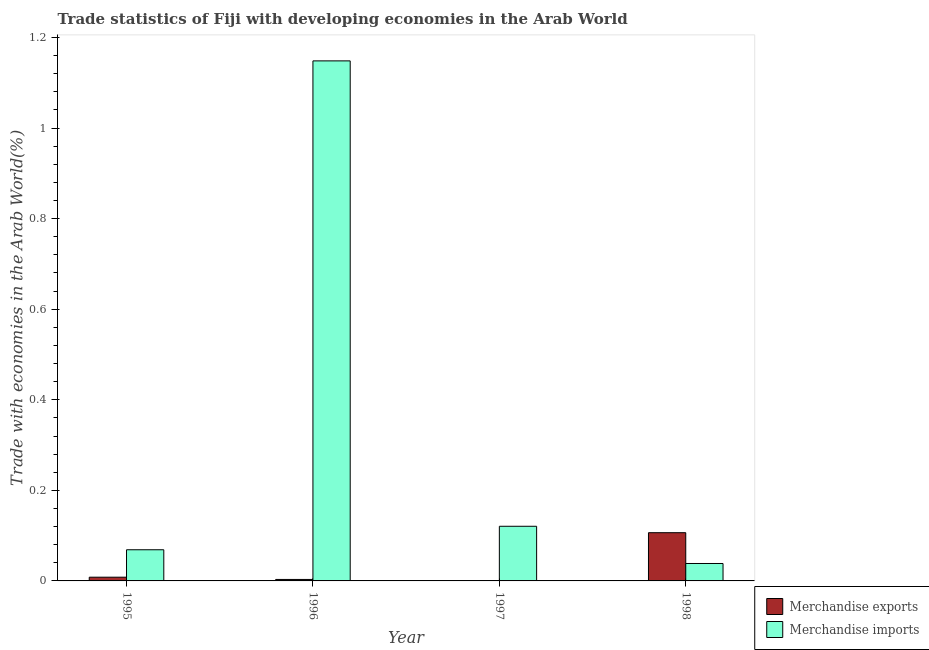How many groups of bars are there?
Your answer should be very brief. 4. How many bars are there on the 2nd tick from the left?
Provide a succinct answer. 2. What is the label of the 4th group of bars from the left?
Your answer should be very brief. 1998. What is the merchandise exports in 1996?
Keep it short and to the point. 0. Across all years, what is the maximum merchandise exports?
Make the answer very short. 0.11. Across all years, what is the minimum merchandise exports?
Ensure brevity in your answer.  0. What is the total merchandise imports in the graph?
Offer a terse response. 1.38. What is the difference between the merchandise exports in 1995 and that in 1997?
Ensure brevity in your answer.  0.01. What is the difference between the merchandise imports in 1996 and the merchandise exports in 1998?
Give a very brief answer. 1.11. What is the average merchandise imports per year?
Offer a very short reply. 0.34. What is the ratio of the merchandise exports in 1997 to that in 1998?
Your answer should be compact. 0. What is the difference between the highest and the second highest merchandise exports?
Provide a short and direct response. 0.1. What is the difference between the highest and the lowest merchandise imports?
Ensure brevity in your answer.  1.11. In how many years, is the merchandise exports greater than the average merchandise exports taken over all years?
Your answer should be compact. 1. Is the sum of the merchandise exports in 1996 and 1998 greater than the maximum merchandise imports across all years?
Offer a terse response. Yes. What does the 1st bar from the left in 1997 represents?
Provide a succinct answer. Merchandise exports. How many bars are there?
Your answer should be compact. 8. What is the difference between two consecutive major ticks on the Y-axis?
Make the answer very short. 0.2. Are the values on the major ticks of Y-axis written in scientific E-notation?
Provide a succinct answer. No. Does the graph contain grids?
Your answer should be compact. No. How many legend labels are there?
Your answer should be very brief. 2. What is the title of the graph?
Make the answer very short. Trade statistics of Fiji with developing economies in the Arab World. What is the label or title of the X-axis?
Offer a very short reply. Year. What is the label or title of the Y-axis?
Your answer should be compact. Trade with economies in the Arab World(%). What is the Trade with economies in the Arab World(%) of Merchandise exports in 1995?
Your response must be concise. 0.01. What is the Trade with economies in the Arab World(%) in Merchandise imports in 1995?
Make the answer very short. 0.07. What is the Trade with economies in the Arab World(%) of Merchandise exports in 1996?
Provide a succinct answer. 0. What is the Trade with economies in the Arab World(%) in Merchandise imports in 1996?
Offer a terse response. 1.15. What is the Trade with economies in the Arab World(%) in Merchandise exports in 1997?
Give a very brief answer. 0. What is the Trade with economies in the Arab World(%) in Merchandise imports in 1997?
Give a very brief answer. 0.12. What is the Trade with economies in the Arab World(%) of Merchandise exports in 1998?
Your answer should be very brief. 0.11. What is the Trade with economies in the Arab World(%) of Merchandise imports in 1998?
Your answer should be compact. 0.04. Across all years, what is the maximum Trade with economies in the Arab World(%) in Merchandise exports?
Provide a succinct answer. 0.11. Across all years, what is the maximum Trade with economies in the Arab World(%) of Merchandise imports?
Give a very brief answer. 1.15. Across all years, what is the minimum Trade with economies in the Arab World(%) in Merchandise exports?
Ensure brevity in your answer.  0. Across all years, what is the minimum Trade with economies in the Arab World(%) in Merchandise imports?
Provide a short and direct response. 0.04. What is the total Trade with economies in the Arab World(%) of Merchandise exports in the graph?
Your answer should be compact. 0.12. What is the total Trade with economies in the Arab World(%) of Merchandise imports in the graph?
Give a very brief answer. 1.38. What is the difference between the Trade with economies in the Arab World(%) of Merchandise exports in 1995 and that in 1996?
Give a very brief answer. 0.01. What is the difference between the Trade with economies in the Arab World(%) of Merchandise imports in 1995 and that in 1996?
Provide a succinct answer. -1.08. What is the difference between the Trade with economies in the Arab World(%) in Merchandise exports in 1995 and that in 1997?
Provide a short and direct response. 0.01. What is the difference between the Trade with economies in the Arab World(%) in Merchandise imports in 1995 and that in 1997?
Give a very brief answer. -0.05. What is the difference between the Trade with economies in the Arab World(%) of Merchandise exports in 1995 and that in 1998?
Provide a succinct answer. -0.1. What is the difference between the Trade with economies in the Arab World(%) of Merchandise imports in 1995 and that in 1998?
Give a very brief answer. 0.03. What is the difference between the Trade with economies in the Arab World(%) in Merchandise exports in 1996 and that in 1997?
Offer a very short reply. 0. What is the difference between the Trade with economies in the Arab World(%) of Merchandise imports in 1996 and that in 1997?
Keep it short and to the point. 1.03. What is the difference between the Trade with economies in the Arab World(%) of Merchandise exports in 1996 and that in 1998?
Offer a very short reply. -0.1. What is the difference between the Trade with economies in the Arab World(%) in Merchandise imports in 1996 and that in 1998?
Offer a terse response. 1.11. What is the difference between the Trade with economies in the Arab World(%) of Merchandise exports in 1997 and that in 1998?
Your response must be concise. -0.11. What is the difference between the Trade with economies in the Arab World(%) in Merchandise imports in 1997 and that in 1998?
Give a very brief answer. 0.08. What is the difference between the Trade with economies in the Arab World(%) of Merchandise exports in 1995 and the Trade with economies in the Arab World(%) of Merchandise imports in 1996?
Ensure brevity in your answer.  -1.14. What is the difference between the Trade with economies in the Arab World(%) of Merchandise exports in 1995 and the Trade with economies in the Arab World(%) of Merchandise imports in 1997?
Keep it short and to the point. -0.11. What is the difference between the Trade with economies in the Arab World(%) of Merchandise exports in 1995 and the Trade with economies in the Arab World(%) of Merchandise imports in 1998?
Provide a short and direct response. -0.03. What is the difference between the Trade with economies in the Arab World(%) of Merchandise exports in 1996 and the Trade with economies in the Arab World(%) of Merchandise imports in 1997?
Make the answer very short. -0.12. What is the difference between the Trade with economies in the Arab World(%) of Merchandise exports in 1996 and the Trade with economies in the Arab World(%) of Merchandise imports in 1998?
Provide a short and direct response. -0.04. What is the difference between the Trade with economies in the Arab World(%) of Merchandise exports in 1997 and the Trade with economies in the Arab World(%) of Merchandise imports in 1998?
Make the answer very short. -0.04. What is the average Trade with economies in the Arab World(%) in Merchandise exports per year?
Offer a very short reply. 0.03. What is the average Trade with economies in the Arab World(%) of Merchandise imports per year?
Offer a very short reply. 0.34. In the year 1995, what is the difference between the Trade with economies in the Arab World(%) in Merchandise exports and Trade with economies in the Arab World(%) in Merchandise imports?
Offer a terse response. -0.06. In the year 1996, what is the difference between the Trade with economies in the Arab World(%) of Merchandise exports and Trade with economies in the Arab World(%) of Merchandise imports?
Offer a very short reply. -1.15. In the year 1997, what is the difference between the Trade with economies in the Arab World(%) of Merchandise exports and Trade with economies in the Arab World(%) of Merchandise imports?
Offer a very short reply. -0.12. In the year 1998, what is the difference between the Trade with economies in the Arab World(%) in Merchandise exports and Trade with economies in the Arab World(%) in Merchandise imports?
Your answer should be compact. 0.07. What is the ratio of the Trade with economies in the Arab World(%) in Merchandise exports in 1995 to that in 1996?
Give a very brief answer. 2.52. What is the ratio of the Trade with economies in the Arab World(%) of Merchandise imports in 1995 to that in 1996?
Keep it short and to the point. 0.06. What is the ratio of the Trade with economies in the Arab World(%) in Merchandise exports in 1995 to that in 1997?
Your answer should be very brief. 74.71. What is the ratio of the Trade with economies in the Arab World(%) in Merchandise imports in 1995 to that in 1997?
Provide a succinct answer. 0.57. What is the ratio of the Trade with economies in the Arab World(%) of Merchandise exports in 1995 to that in 1998?
Ensure brevity in your answer.  0.08. What is the ratio of the Trade with economies in the Arab World(%) in Merchandise imports in 1995 to that in 1998?
Your answer should be compact. 1.79. What is the ratio of the Trade with economies in the Arab World(%) of Merchandise exports in 1996 to that in 1997?
Offer a terse response. 29.63. What is the ratio of the Trade with economies in the Arab World(%) of Merchandise imports in 1996 to that in 1997?
Make the answer very short. 9.52. What is the ratio of the Trade with economies in the Arab World(%) in Merchandise exports in 1996 to that in 1998?
Provide a succinct answer. 0.03. What is the ratio of the Trade with economies in the Arab World(%) of Merchandise imports in 1996 to that in 1998?
Your answer should be very brief. 29.85. What is the ratio of the Trade with economies in the Arab World(%) of Merchandise imports in 1997 to that in 1998?
Your answer should be compact. 3.14. What is the difference between the highest and the second highest Trade with economies in the Arab World(%) in Merchandise exports?
Offer a very short reply. 0.1. What is the difference between the highest and the second highest Trade with economies in the Arab World(%) of Merchandise imports?
Give a very brief answer. 1.03. What is the difference between the highest and the lowest Trade with economies in the Arab World(%) of Merchandise exports?
Make the answer very short. 0.11. What is the difference between the highest and the lowest Trade with economies in the Arab World(%) of Merchandise imports?
Your answer should be compact. 1.11. 